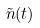Convert formula to latex. <formula><loc_0><loc_0><loc_500><loc_500>\tilde { n } ( t )</formula> 